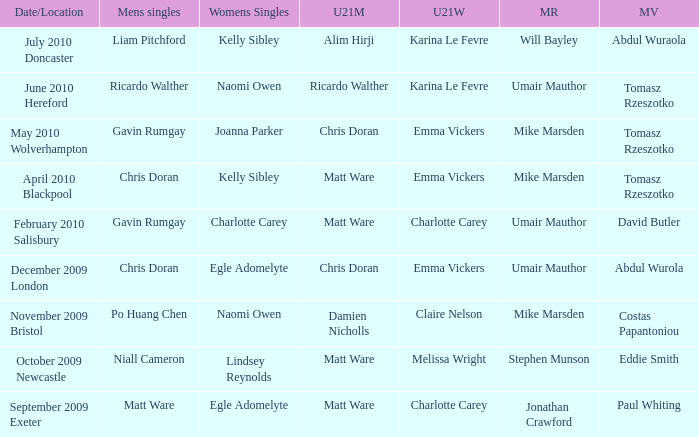Who was the U21 Mens winner when Mike Marsden was the mixed restricted winner and Claire Nelson was the U21 Womens winner?  Damien Nicholls. 